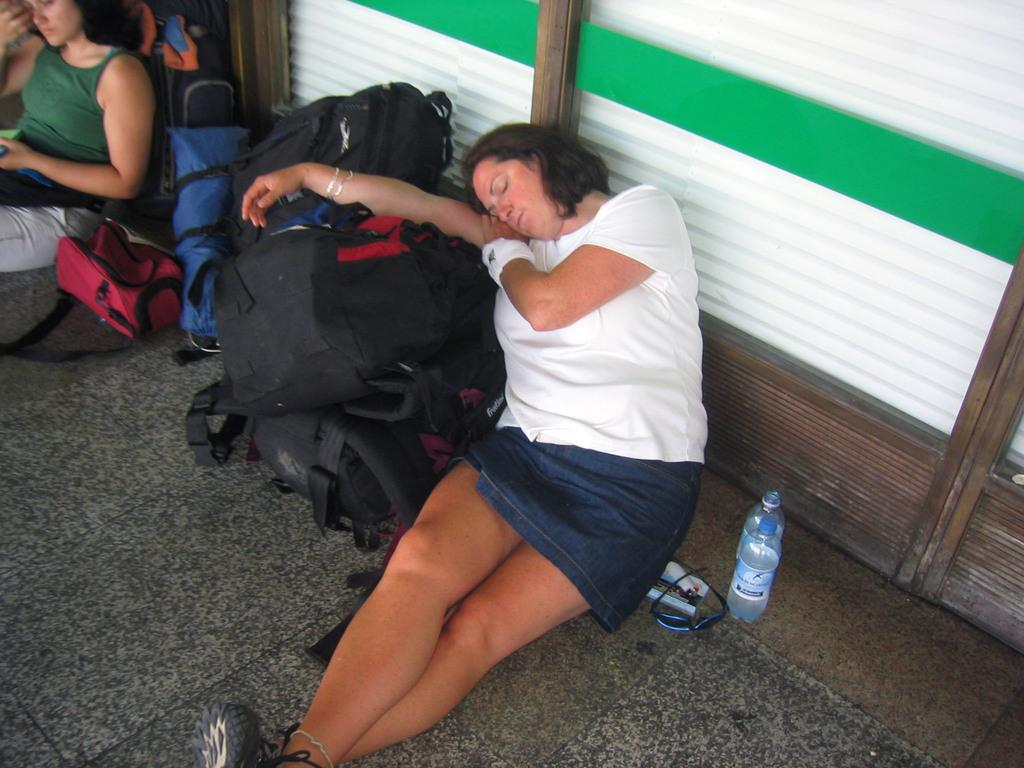What is the lady in the center of the image doing? The lady in the center of the image is lying on the bags. What objects are placed beside the lady lying down? There are bottles and glasses placed beside her. What is the position of the other lady in the image? The other lady is sitting on the left side of the image. What type of items can be seen in large quantities in the image? There are many backpacks visible in the image. What type of powder is being used by the lady sitting on the left side of the image? There is no powder visible in the image, and the lady sitting on the left side of the image is not using any powder. 